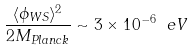Convert formula to latex. <formula><loc_0><loc_0><loc_500><loc_500>\frac { \langle \phi _ { W S } \rangle ^ { 2 } } { 2 M _ { P l a n c k } } \sim 3 \times 1 0 ^ { - 6 } \ e V</formula> 